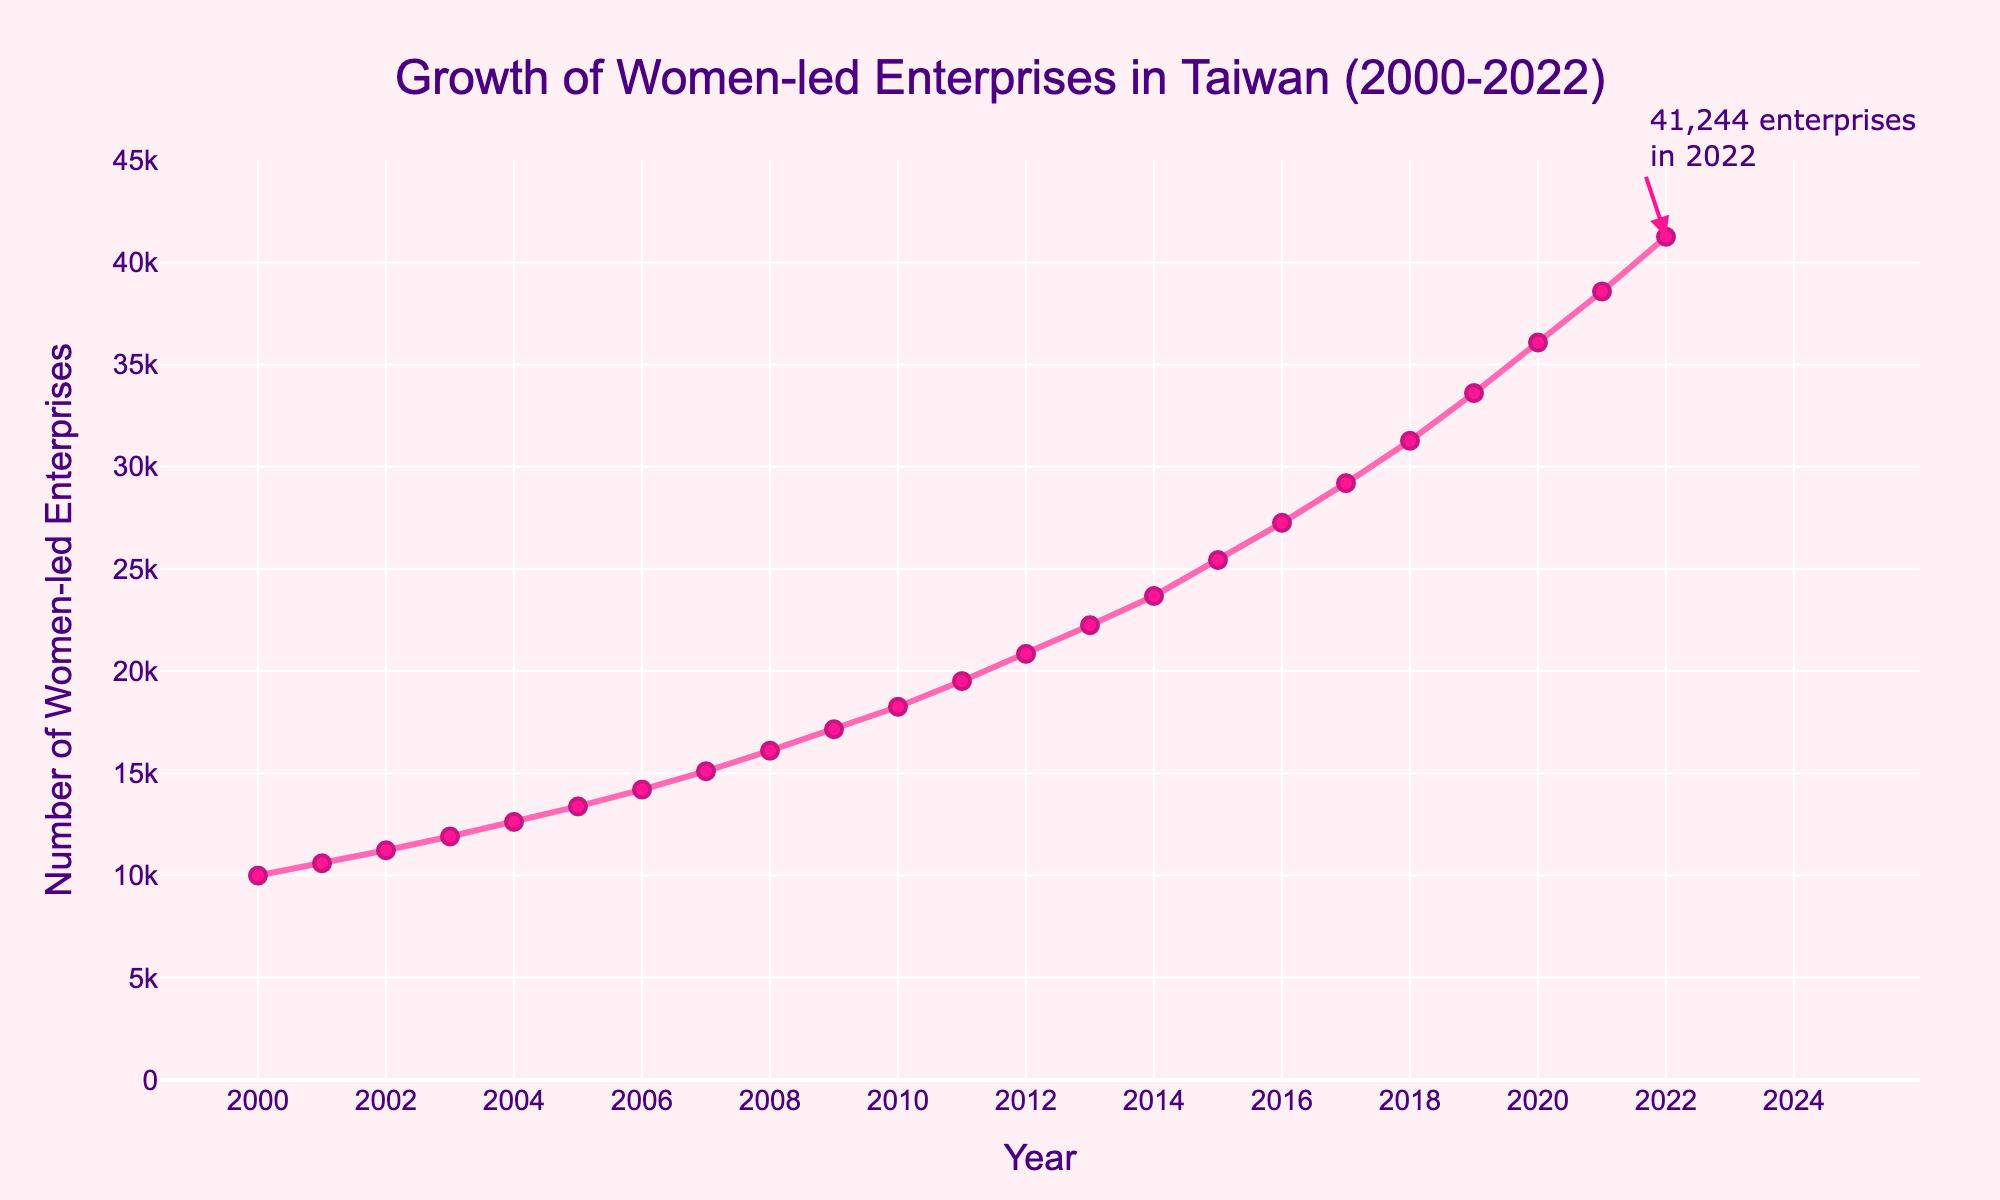How many women-led enterprises were there in Taiwan in the year 2000? Look at the data point for the year 2000 on the plot. The value indicated is 10,000.
Answer: 10,000 What is the title of the figure? The title is placed at the top of the figure. It reads "Growth of Women-led Enterprises in Taiwan (2000-2022)".
Answer: Growth of Women-led Enterprises in Taiwan (2000-2022) In which year did women-led enterprises in Taiwan exceed 20,000? Check the trend line and locate the point where the number reaches slightly above 20,000. This occurs in 2012.
Answer: 2012 How much did the number of women-led enterprises increase from 2015 to 2016? In 2015, the number was 25,434 and in 2016, it was 27,254. Calculate the difference: 27,254 - 25,434 = 1,820.
Answer: 1,820 Which year had the highest percent growth in women-led enterprises? Among the yearly percentage growths, the highest growth is depicted as 7.46% in 2019.
Answer: 2019 Which period saw a continuous yearly growth rate of exactly 6%? Scan the percentage column to find consecutive years with a 6% increase: from 2001 to 2006.
Answer: 2001 to 2006 How much did the number of women-led enterprises in Taiwan grow from 2000 to 2022? The initial value in 2000 was 10,000, and the final value in 2022 was 41,244. Calculate the difference: 41,244 - 10,000 = 31,244.
Answer: 31,244 What is the percentage growth rate for the year 2021? Check the figure annotation or table provided and find the value for 2021, which is 6.92%.
Answer: 6.92% Between 2017 and 2018, how did the growth rate change, and which year had a higher rate? Look at the growth rates: 7.11% in 2017 and 7.16% in 2018. Compare the two: 7.16% > 7.11%. So, 2018 had a higher growth rate.
Answer: 2018 Calculate the average yearly growth rate from 2017 to 2020. Sum the yearly growth rates for 2017 (7.11%), 2018 (7.16%), 2019 (7.46%), and 2020 (7.36%), then divide by 4. (7.11 + 7.16 + 7.46 + 7.36) / 4 = 7.27.
Answer: 7.27 